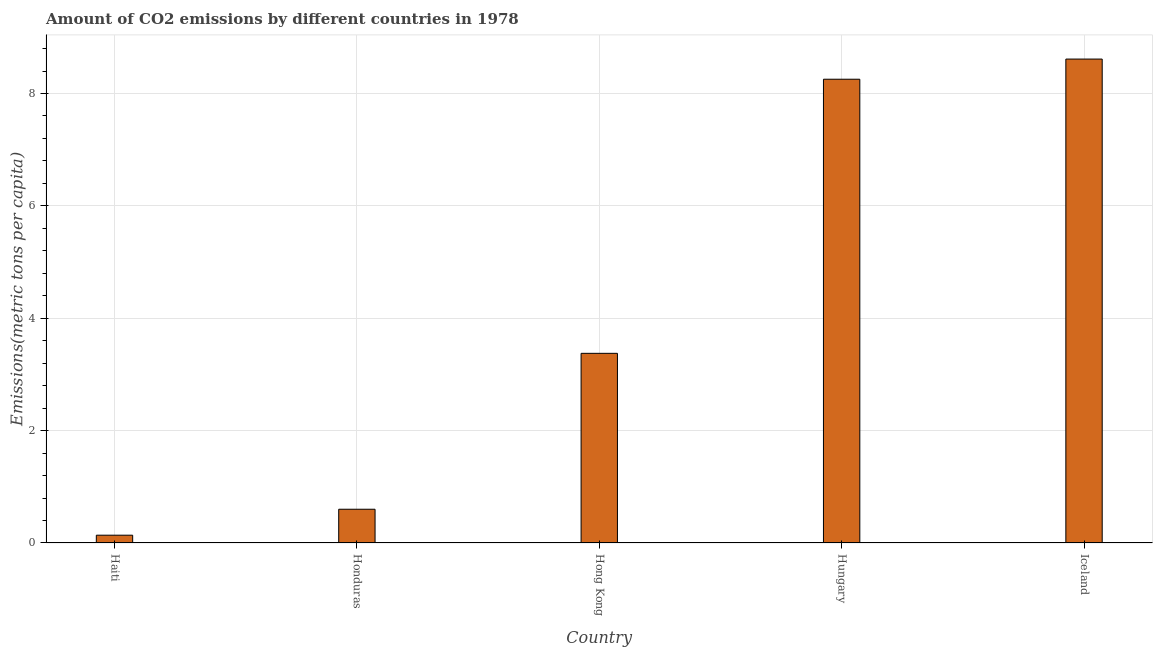Does the graph contain any zero values?
Give a very brief answer. No. Does the graph contain grids?
Keep it short and to the point. Yes. What is the title of the graph?
Your answer should be very brief. Amount of CO2 emissions by different countries in 1978. What is the label or title of the Y-axis?
Your response must be concise. Emissions(metric tons per capita). What is the amount of co2 emissions in Honduras?
Provide a succinct answer. 0.6. Across all countries, what is the maximum amount of co2 emissions?
Offer a very short reply. 8.61. Across all countries, what is the minimum amount of co2 emissions?
Offer a very short reply. 0.14. In which country was the amount of co2 emissions maximum?
Give a very brief answer. Iceland. In which country was the amount of co2 emissions minimum?
Your response must be concise. Haiti. What is the sum of the amount of co2 emissions?
Your answer should be very brief. 20.98. What is the difference between the amount of co2 emissions in Haiti and Iceland?
Offer a terse response. -8.47. What is the average amount of co2 emissions per country?
Make the answer very short. 4.2. What is the median amount of co2 emissions?
Offer a very short reply. 3.38. What is the ratio of the amount of co2 emissions in Honduras to that in Hungary?
Your answer should be compact. 0.07. Is the amount of co2 emissions in Haiti less than that in Hungary?
Provide a succinct answer. Yes. What is the difference between the highest and the second highest amount of co2 emissions?
Offer a terse response. 0.36. What is the difference between the highest and the lowest amount of co2 emissions?
Provide a short and direct response. 8.47. In how many countries, is the amount of co2 emissions greater than the average amount of co2 emissions taken over all countries?
Your response must be concise. 2. What is the difference between two consecutive major ticks on the Y-axis?
Provide a short and direct response. 2. Are the values on the major ticks of Y-axis written in scientific E-notation?
Offer a terse response. No. What is the Emissions(metric tons per capita) in Haiti?
Keep it short and to the point. 0.14. What is the Emissions(metric tons per capita) in Honduras?
Ensure brevity in your answer.  0.6. What is the Emissions(metric tons per capita) of Hong Kong?
Your answer should be very brief. 3.38. What is the Emissions(metric tons per capita) of Hungary?
Provide a succinct answer. 8.25. What is the Emissions(metric tons per capita) of Iceland?
Your answer should be compact. 8.61. What is the difference between the Emissions(metric tons per capita) in Haiti and Honduras?
Your response must be concise. -0.46. What is the difference between the Emissions(metric tons per capita) in Haiti and Hong Kong?
Your answer should be compact. -3.24. What is the difference between the Emissions(metric tons per capita) in Haiti and Hungary?
Make the answer very short. -8.11. What is the difference between the Emissions(metric tons per capita) in Haiti and Iceland?
Give a very brief answer. -8.47. What is the difference between the Emissions(metric tons per capita) in Honduras and Hong Kong?
Offer a very short reply. -2.77. What is the difference between the Emissions(metric tons per capita) in Honduras and Hungary?
Give a very brief answer. -7.65. What is the difference between the Emissions(metric tons per capita) in Honduras and Iceland?
Your answer should be very brief. -8.01. What is the difference between the Emissions(metric tons per capita) in Hong Kong and Hungary?
Ensure brevity in your answer.  -4.88. What is the difference between the Emissions(metric tons per capita) in Hong Kong and Iceland?
Ensure brevity in your answer.  -5.24. What is the difference between the Emissions(metric tons per capita) in Hungary and Iceland?
Provide a succinct answer. -0.36. What is the ratio of the Emissions(metric tons per capita) in Haiti to that in Honduras?
Ensure brevity in your answer.  0.23. What is the ratio of the Emissions(metric tons per capita) in Haiti to that in Hong Kong?
Offer a very short reply. 0.04. What is the ratio of the Emissions(metric tons per capita) in Haiti to that in Hungary?
Ensure brevity in your answer.  0.02. What is the ratio of the Emissions(metric tons per capita) in Haiti to that in Iceland?
Make the answer very short. 0.02. What is the ratio of the Emissions(metric tons per capita) in Honduras to that in Hong Kong?
Keep it short and to the point. 0.18. What is the ratio of the Emissions(metric tons per capita) in Honduras to that in Hungary?
Ensure brevity in your answer.  0.07. What is the ratio of the Emissions(metric tons per capita) in Honduras to that in Iceland?
Offer a terse response. 0.07. What is the ratio of the Emissions(metric tons per capita) in Hong Kong to that in Hungary?
Your response must be concise. 0.41. What is the ratio of the Emissions(metric tons per capita) in Hong Kong to that in Iceland?
Your response must be concise. 0.39. What is the ratio of the Emissions(metric tons per capita) in Hungary to that in Iceland?
Keep it short and to the point. 0.96. 